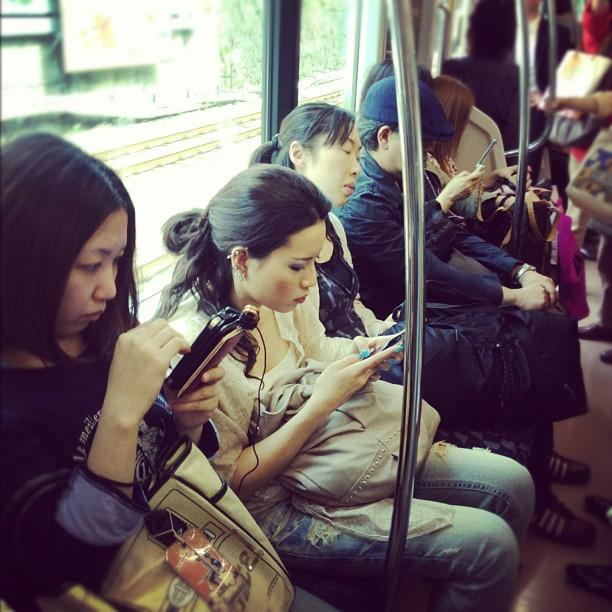If one was standing what would assist in maintaining their balance? pole 